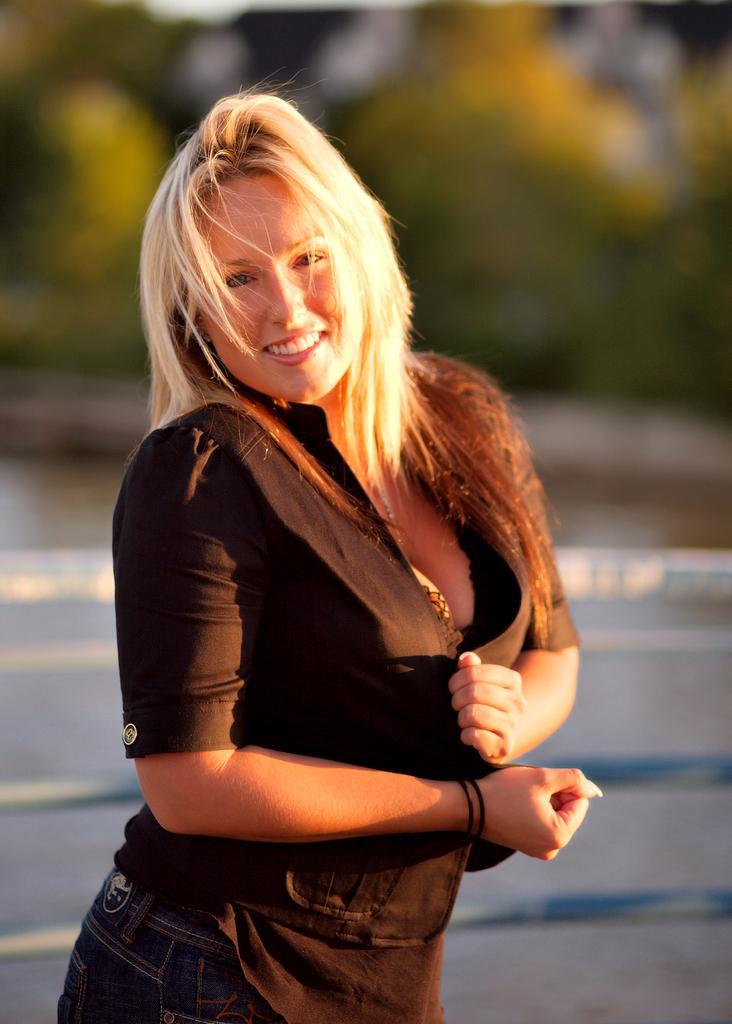Describe this image in one or two sentences. In this image I can see a woman wearing black color dress is standing and smiling. In the background I can see few trees, the ground and the sky. 